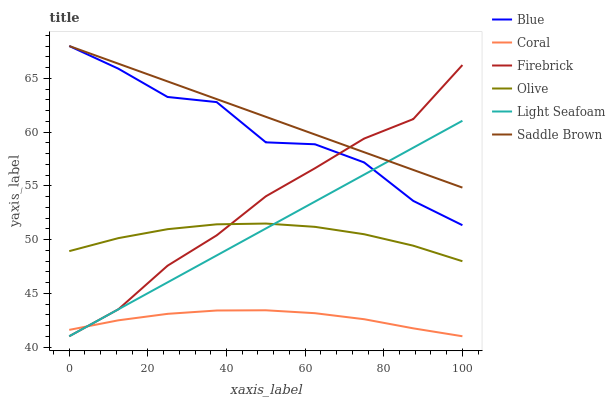Does Saddle Brown have the minimum area under the curve?
Answer yes or no. No. Does Coral have the maximum area under the curve?
Answer yes or no. No. Is Coral the smoothest?
Answer yes or no. No. Is Coral the roughest?
Answer yes or no. No. Does Saddle Brown have the lowest value?
Answer yes or no. No. Does Coral have the highest value?
Answer yes or no. No. Is Olive less than Blue?
Answer yes or no. Yes. Is Olive greater than Coral?
Answer yes or no. Yes. Does Olive intersect Blue?
Answer yes or no. No. 